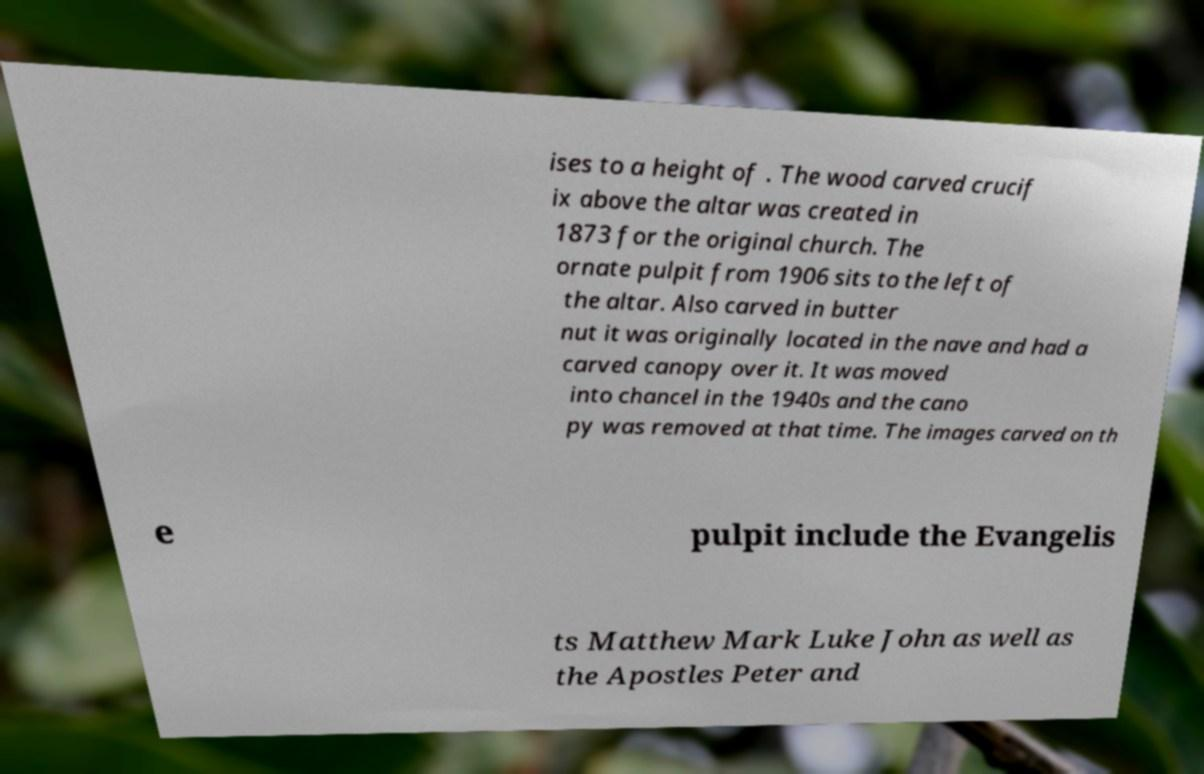Could you assist in decoding the text presented in this image and type it out clearly? ises to a height of . The wood carved crucif ix above the altar was created in 1873 for the original church. The ornate pulpit from 1906 sits to the left of the altar. Also carved in butter nut it was originally located in the nave and had a carved canopy over it. It was moved into chancel in the 1940s and the cano py was removed at that time. The images carved on th e pulpit include the Evangelis ts Matthew Mark Luke John as well as the Apostles Peter and 